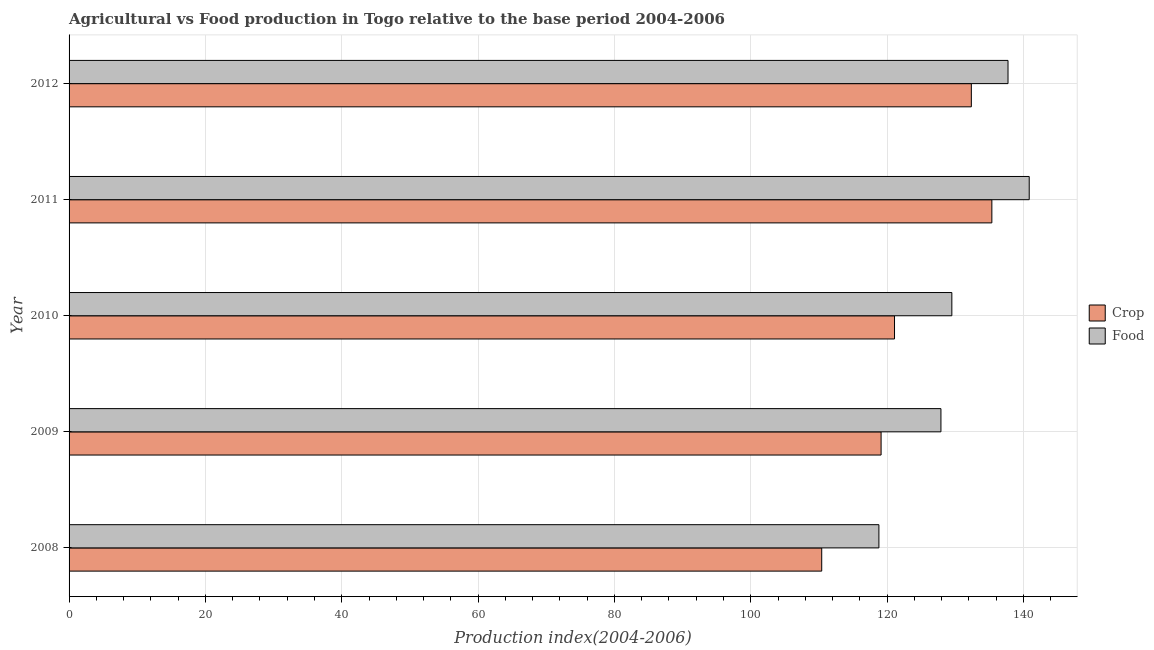Are the number of bars on each tick of the Y-axis equal?
Your answer should be compact. Yes. How many bars are there on the 4th tick from the top?
Your answer should be compact. 2. How many bars are there on the 1st tick from the bottom?
Keep it short and to the point. 2. What is the label of the 3rd group of bars from the top?
Your answer should be compact. 2010. What is the food production index in 2009?
Keep it short and to the point. 127.9. Across all years, what is the maximum food production index?
Give a very brief answer. 140.85. Across all years, what is the minimum crop production index?
Your response must be concise. 110.41. In which year was the food production index minimum?
Ensure brevity in your answer.  2008. What is the total crop production index in the graph?
Ensure brevity in your answer.  618.35. What is the difference between the crop production index in 2009 and that in 2011?
Offer a terse response. -16.25. What is the difference between the crop production index in 2012 and the food production index in 2010?
Make the answer very short. 2.86. What is the average food production index per year?
Your answer should be very brief. 130.96. In the year 2010, what is the difference between the crop production index and food production index?
Keep it short and to the point. -8.41. In how many years, is the food production index greater than 120 ?
Your response must be concise. 4. What is the difference between the highest and the second highest crop production index?
Your answer should be very brief. 3.01. What is the difference between the highest and the lowest crop production index?
Offer a terse response. 24.96. What does the 1st bar from the top in 2012 represents?
Keep it short and to the point. Food. What does the 1st bar from the bottom in 2010 represents?
Give a very brief answer. Crop. Are the values on the major ticks of X-axis written in scientific E-notation?
Make the answer very short. No. Does the graph contain any zero values?
Give a very brief answer. No. What is the title of the graph?
Your answer should be compact. Agricultural vs Food production in Togo relative to the base period 2004-2006. Does "By country of origin" appear as one of the legend labels in the graph?
Your answer should be compact. No. What is the label or title of the X-axis?
Offer a terse response. Production index(2004-2006). What is the label or title of the Y-axis?
Provide a succinct answer. Year. What is the Production index(2004-2006) of Crop in 2008?
Your answer should be very brief. 110.41. What is the Production index(2004-2006) in Food in 2008?
Make the answer very short. 118.8. What is the Production index(2004-2006) of Crop in 2009?
Provide a succinct answer. 119.12. What is the Production index(2004-2006) in Food in 2009?
Your response must be concise. 127.9. What is the Production index(2004-2006) of Crop in 2010?
Your answer should be very brief. 121.09. What is the Production index(2004-2006) in Food in 2010?
Offer a terse response. 129.5. What is the Production index(2004-2006) in Crop in 2011?
Offer a terse response. 135.37. What is the Production index(2004-2006) in Food in 2011?
Provide a succinct answer. 140.85. What is the Production index(2004-2006) in Crop in 2012?
Your answer should be very brief. 132.36. What is the Production index(2004-2006) of Food in 2012?
Make the answer very short. 137.74. Across all years, what is the maximum Production index(2004-2006) in Crop?
Offer a very short reply. 135.37. Across all years, what is the maximum Production index(2004-2006) in Food?
Keep it short and to the point. 140.85. Across all years, what is the minimum Production index(2004-2006) of Crop?
Your answer should be very brief. 110.41. Across all years, what is the minimum Production index(2004-2006) of Food?
Keep it short and to the point. 118.8. What is the total Production index(2004-2006) of Crop in the graph?
Make the answer very short. 618.35. What is the total Production index(2004-2006) of Food in the graph?
Your response must be concise. 654.79. What is the difference between the Production index(2004-2006) of Crop in 2008 and that in 2009?
Provide a short and direct response. -8.71. What is the difference between the Production index(2004-2006) in Food in 2008 and that in 2009?
Offer a very short reply. -9.1. What is the difference between the Production index(2004-2006) of Crop in 2008 and that in 2010?
Give a very brief answer. -10.68. What is the difference between the Production index(2004-2006) of Crop in 2008 and that in 2011?
Offer a terse response. -24.96. What is the difference between the Production index(2004-2006) of Food in 2008 and that in 2011?
Your answer should be compact. -22.05. What is the difference between the Production index(2004-2006) in Crop in 2008 and that in 2012?
Give a very brief answer. -21.95. What is the difference between the Production index(2004-2006) of Food in 2008 and that in 2012?
Give a very brief answer. -18.94. What is the difference between the Production index(2004-2006) of Crop in 2009 and that in 2010?
Offer a very short reply. -1.97. What is the difference between the Production index(2004-2006) of Food in 2009 and that in 2010?
Give a very brief answer. -1.6. What is the difference between the Production index(2004-2006) in Crop in 2009 and that in 2011?
Offer a very short reply. -16.25. What is the difference between the Production index(2004-2006) in Food in 2009 and that in 2011?
Give a very brief answer. -12.95. What is the difference between the Production index(2004-2006) in Crop in 2009 and that in 2012?
Give a very brief answer. -13.24. What is the difference between the Production index(2004-2006) in Food in 2009 and that in 2012?
Ensure brevity in your answer.  -9.84. What is the difference between the Production index(2004-2006) in Crop in 2010 and that in 2011?
Provide a short and direct response. -14.28. What is the difference between the Production index(2004-2006) of Food in 2010 and that in 2011?
Provide a short and direct response. -11.35. What is the difference between the Production index(2004-2006) of Crop in 2010 and that in 2012?
Provide a succinct answer. -11.27. What is the difference between the Production index(2004-2006) in Food in 2010 and that in 2012?
Offer a very short reply. -8.24. What is the difference between the Production index(2004-2006) of Crop in 2011 and that in 2012?
Provide a succinct answer. 3.01. What is the difference between the Production index(2004-2006) in Food in 2011 and that in 2012?
Provide a short and direct response. 3.11. What is the difference between the Production index(2004-2006) of Crop in 2008 and the Production index(2004-2006) of Food in 2009?
Ensure brevity in your answer.  -17.49. What is the difference between the Production index(2004-2006) in Crop in 2008 and the Production index(2004-2006) in Food in 2010?
Provide a short and direct response. -19.09. What is the difference between the Production index(2004-2006) in Crop in 2008 and the Production index(2004-2006) in Food in 2011?
Offer a very short reply. -30.44. What is the difference between the Production index(2004-2006) in Crop in 2008 and the Production index(2004-2006) in Food in 2012?
Make the answer very short. -27.33. What is the difference between the Production index(2004-2006) in Crop in 2009 and the Production index(2004-2006) in Food in 2010?
Provide a succinct answer. -10.38. What is the difference between the Production index(2004-2006) in Crop in 2009 and the Production index(2004-2006) in Food in 2011?
Give a very brief answer. -21.73. What is the difference between the Production index(2004-2006) in Crop in 2009 and the Production index(2004-2006) in Food in 2012?
Keep it short and to the point. -18.62. What is the difference between the Production index(2004-2006) in Crop in 2010 and the Production index(2004-2006) in Food in 2011?
Provide a short and direct response. -19.76. What is the difference between the Production index(2004-2006) in Crop in 2010 and the Production index(2004-2006) in Food in 2012?
Give a very brief answer. -16.65. What is the difference between the Production index(2004-2006) in Crop in 2011 and the Production index(2004-2006) in Food in 2012?
Your answer should be compact. -2.37. What is the average Production index(2004-2006) of Crop per year?
Provide a succinct answer. 123.67. What is the average Production index(2004-2006) of Food per year?
Your answer should be very brief. 130.96. In the year 2008, what is the difference between the Production index(2004-2006) of Crop and Production index(2004-2006) of Food?
Keep it short and to the point. -8.39. In the year 2009, what is the difference between the Production index(2004-2006) in Crop and Production index(2004-2006) in Food?
Your answer should be compact. -8.78. In the year 2010, what is the difference between the Production index(2004-2006) of Crop and Production index(2004-2006) of Food?
Your answer should be very brief. -8.41. In the year 2011, what is the difference between the Production index(2004-2006) of Crop and Production index(2004-2006) of Food?
Your answer should be compact. -5.48. In the year 2012, what is the difference between the Production index(2004-2006) of Crop and Production index(2004-2006) of Food?
Offer a terse response. -5.38. What is the ratio of the Production index(2004-2006) in Crop in 2008 to that in 2009?
Your response must be concise. 0.93. What is the ratio of the Production index(2004-2006) of Food in 2008 to that in 2009?
Your answer should be compact. 0.93. What is the ratio of the Production index(2004-2006) in Crop in 2008 to that in 2010?
Make the answer very short. 0.91. What is the ratio of the Production index(2004-2006) in Food in 2008 to that in 2010?
Provide a succinct answer. 0.92. What is the ratio of the Production index(2004-2006) of Crop in 2008 to that in 2011?
Ensure brevity in your answer.  0.82. What is the ratio of the Production index(2004-2006) of Food in 2008 to that in 2011?
Ensure brevity in your answer.  0.84. What is the ratio of the Production index(2004-2006) in Crop in 2008 to that in 2012?
Make the answer very short. 0.83. What is the ratio of the Production index(2004-2006) of Food in 2008 to that in 2012?
Keep it short and to the point. 0.86. What is the ratio of the Production index(2004-2006) in Crop in 2009 to that in 2010?
Make the answer very short. 0.98. What is the ratio of the Production index(2004-2006) in Food in 2009 to that in 2010?
Offer a terse response. 0.99. What is the ratio of the Production index(2004-2006) of Crop in 2009 to that in 2011?
Ensure brevity in your answer.  0.88. What is the ratio of the Production index(2004-2006) in Food in 2009 to that in 2011?
Keep it short and to the point. 0.91. What is the ratio of the Production index(2004-2006) of Crop in 2009 to that in 2012?
Your response must be concise. 0.9. What is the ratio of the Production index(2004-2006) of Food in 2009 to that in 2012?
Your answer should be very brief. 0.93. What is the ratio of the Production index(2004-2006) of Crop in 2010 to that in 2011?
Provide a short and direct response. 0.89. What is the ratio of the Production index(2004-2006) of Food in 2010 to that in 2011?
Give a very brief answer. 0.92. What is the ratio of the Production index(2004-2006) in Crop in 2010 to that in 2012?
Your response must be concise. 0.91. What is the ratio of the Production index(2004-2006) in Food in 2010 to that in 2012?
Offer a terse response. 0.94. What is the ratio of the Production index(2004-2006) of Crop in 2011 to that in 2012?
Provide a succinct answer. 1.02. What is the ratio of the Production index(2004-2006) in Food in 2011 to that in 2012?
Offer a terse response. 1.02. What is the difference between the highest and the second highest Production index(2004-2006) in Crop?
Offer a very short reply. 3.01. What is the difference between the highest and the second highest Production index(2004-2006) of Food?
Make the answer very short. 3.11. What is the difference between the highest and the lowest Production index(2004-2006) in Crop?
Make the answer very short. 24.96. What is the difference between the highest and the lowest Production index(2004-2006) in Food?
Ensure brevity in your answer.  22.05. 